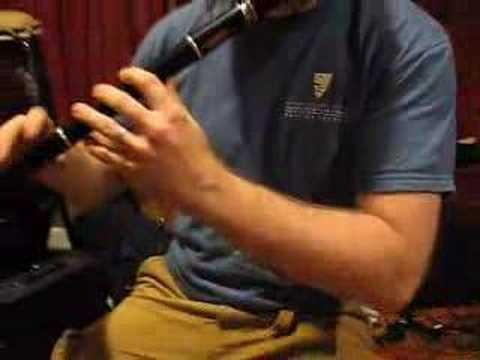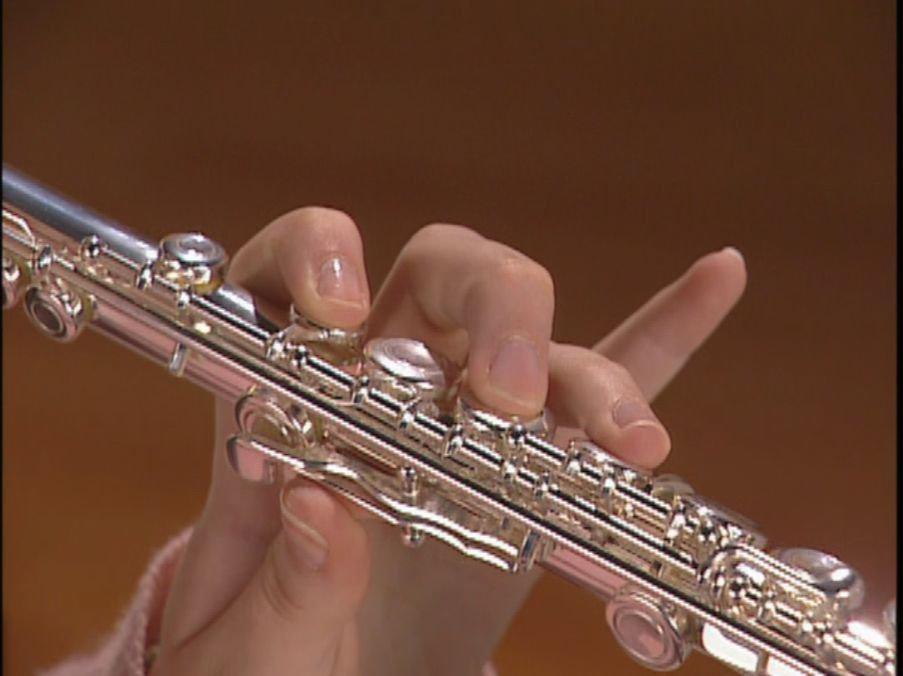The first image is the image on the left, the second image is the image on the right. Examine the images to the left and right. Is the description "There are two flute being played and the end is facing left." accurate? Answer yes or no. No. The first image is the image on the left, the second image is the image on the right. Examine the images to the left and right. Is the description "There are four hands." accurate? Answer yes or no. No. 